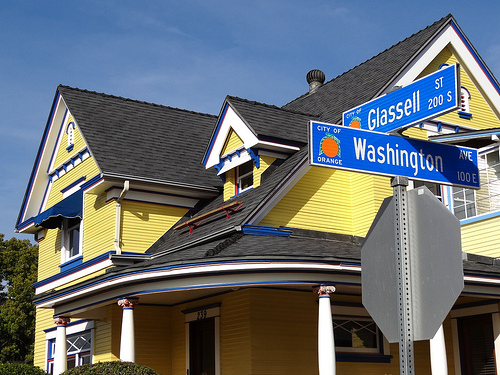<image>
Is there a sign to the left of the house? Yes. From this viewpoint, the sign is positioned to the left side relative to the house. Is the sign to the left of the sign? No. The sign is not to the left of the sign. From this viewpoint, they have a different horizontal relationship. 